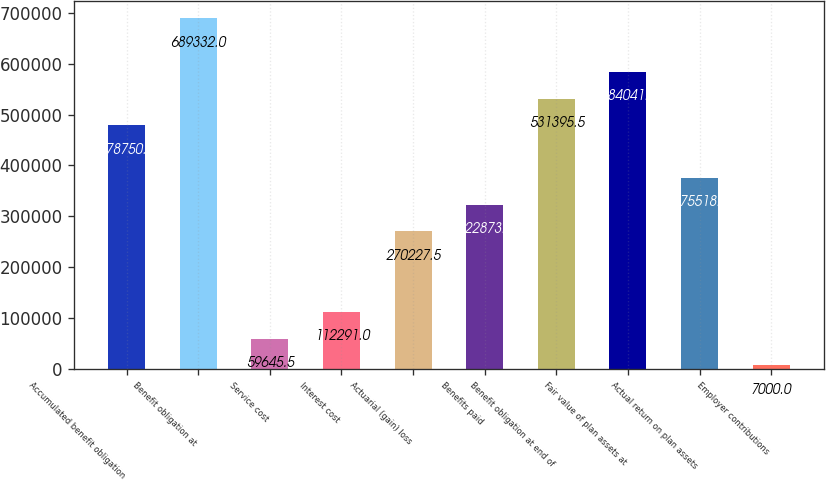Convert chart to OTSL. <chart><loc_0><loc_0><loc_500><loc_500><bar_chart><fcel>Accumulated benefit obligation<fcel>Benefit obligation at<fcel>Service cost<fcel>Interest cost<fcel>Actuarial (gain) loss<fcel>Benefits paid<fcel>Benefit obligation at end of<fcel>Fair value of plan assets at<fcel>Actual return on plan assets<fcel>Employer contributions<nl><fcel>478750<fcel>689332<fcel>59645.5<fcel>112291<fcel>270228<fcel>322873<fcel>531396<fcel>584041<fcel>375518<fcel>7000<nl></chart> 